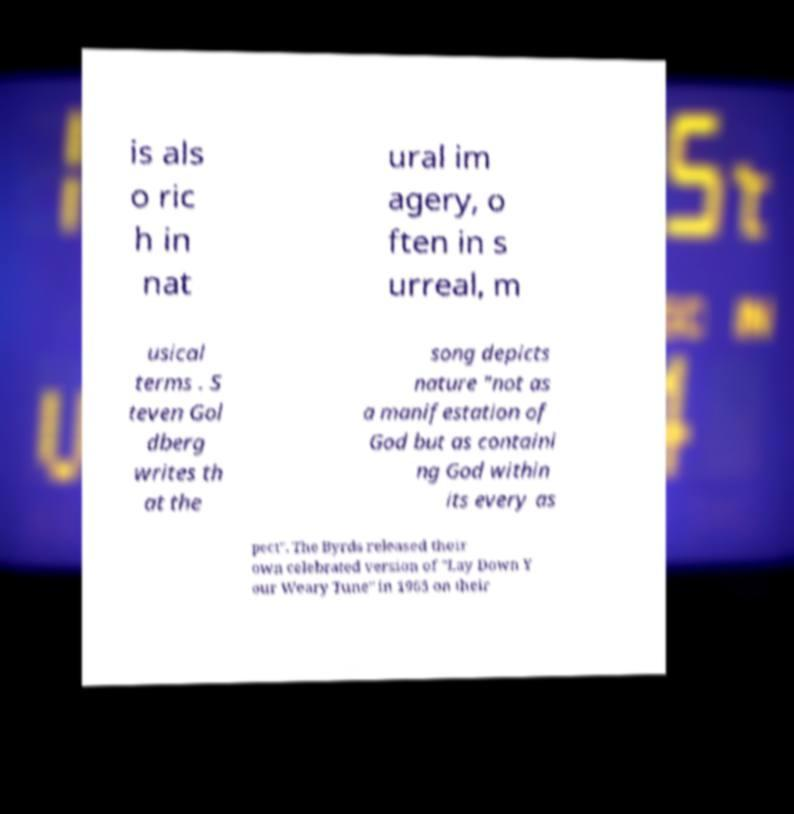Can you accurately transcribe the text from the provided image for me? is als o ric h in nat ural im agery, o ften in s urreal, m usical terms . S teven Gol dberg writes th at the song depicts nature "not as a manifestation of God but as containi ng God within its every as pect". The Byrds released their own celebrated version of "Lay Down Y our Weary Tune" in 1965 on their 